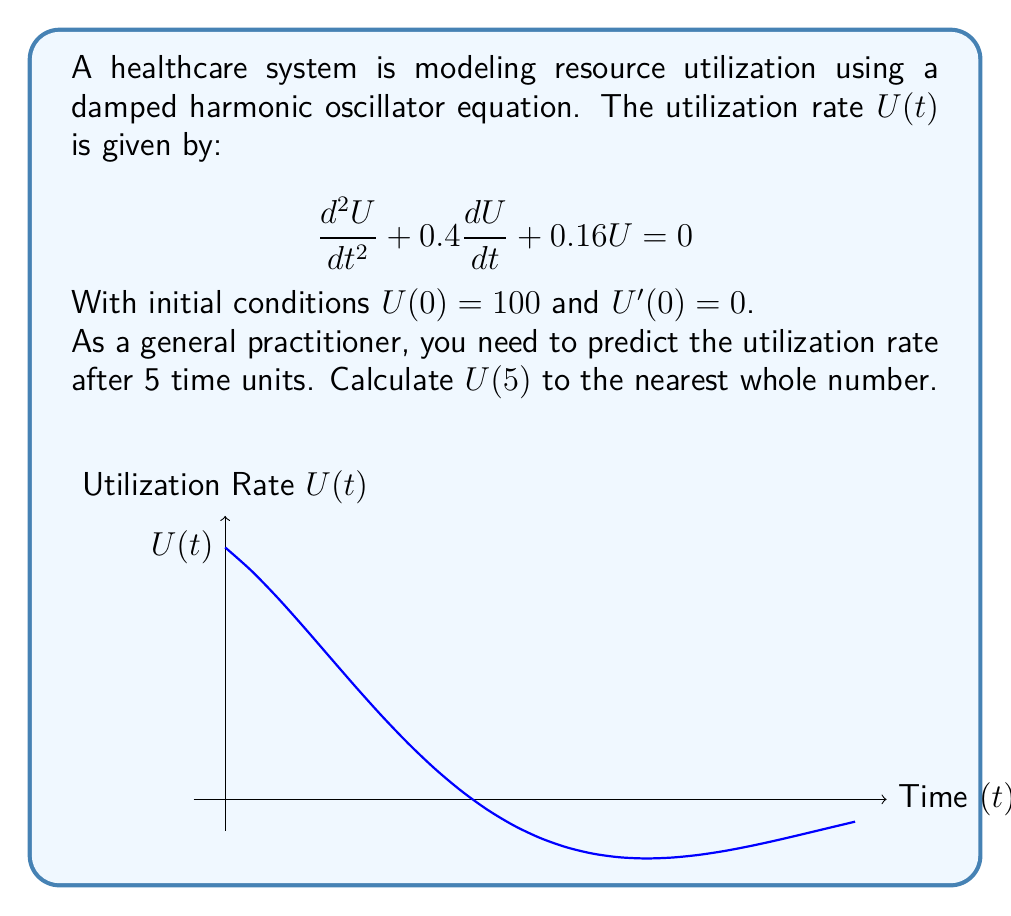Can you solve this math problem? To solve this problem, we follow these steps:

1) The general solution for this damped harmonic oscillator equation is:
   $$U(t) = e^{-\lambda t}(A\cos(\omega t) + B\sin(\omega t))$$

2) We can identify $\lambda = 0.2$ and $\omega = 0.4$ from the given equation.

3) Using the initial conditions:
   $U(0) = 100$, so $A = 100$
   $U'(0) = 0$, which gives us $B = 20$

4) Therefore, our specific solution is:
   $$U(t) = 100e^{-0.2t}(\cos(0.4t) + 0.2\sin(0.4t))$$

5) To find $U(5)$, we substitute $t = 5$:
   $$U(5) = 100e^{-0.2(5)}(\cos(0.4(5)) + 0.2\sin(0.4(5)))$$

6) Calculating:
   $$U(5) = 100 * 0.36788 * (0.36236 + 0.2 * 0.93203)$$
   $$U(5) = 36.788 * (0.36236 + 0.18641)$$
   $$U(5) = 36.788 * 0.54877$$
   $$U(5) = 20.19$$

7) Rounding to the nearest whole number:
   $$U(5) \approx 20$$
Answer: 20 